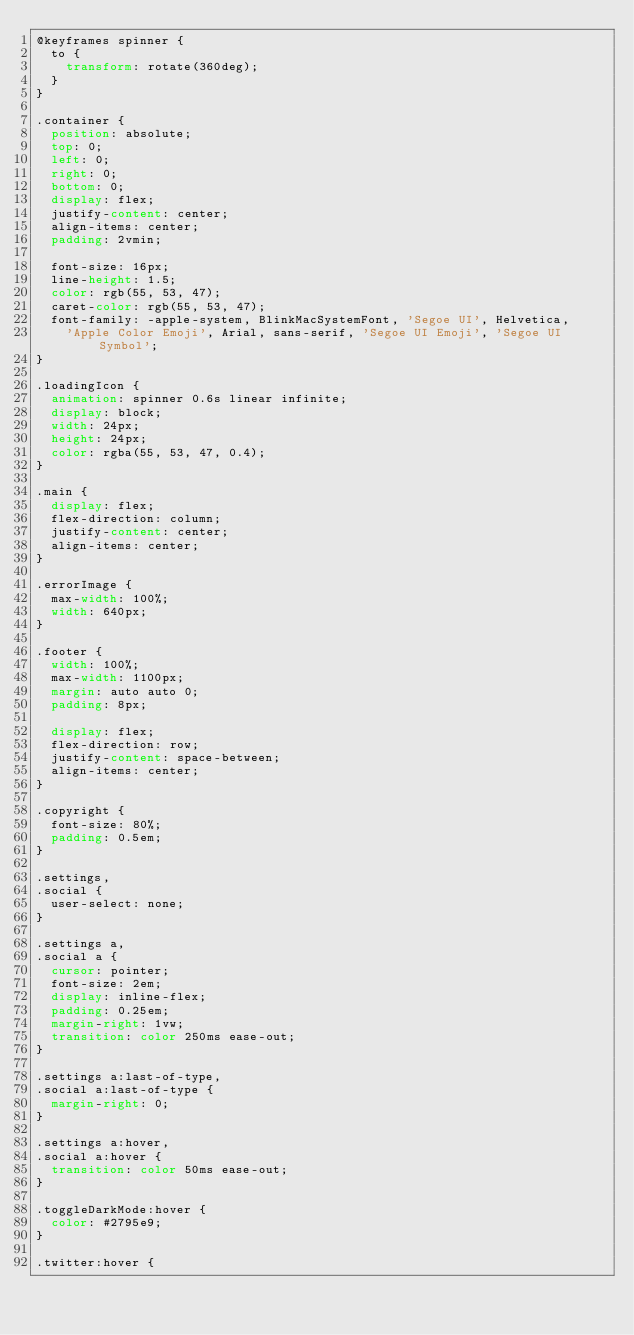Convert code to text. <code><loc_0><loc_0><loc_500><loc_500><_CSS_>@keyframes spinner {
  to {
    transform: rotate(360deg);
  }
}

.container {
  position: absolute;
  top: 0;
  left: 0;
  right: 0;
  bottom: 0;
  display: flex;
  justify-content: center;
  align-items: center;
  padding: 2vmin;

  font-size: 16px;
  line-height: 1.5;
  color: rgb(55, 53, 47);
  caret-color: rgb(55, 53, 47);
  font-family: -apple-system, BlinkMacSystemFont, 'Segoe UI', Helvetica,
    'Apple Color Emoji', Arial, sans-serif, 'Segoe UI Emoji', 'Segoe UI Symbol';
}

.loadingIcon {
  animation: spinner 0.6s linear infinite;
  display: block;
  width: 24px;
  height: 24px;
  color: rgba(55, 53, 47, 0.4);
}

.main {
  display: flex;
  flex-direction: column;
  justify-content: center;
  align-items: center;
}

.errorImage {
  max-width: 100%;
  width: 640px;
}

.footer {
  width: 100%;
  max-width: 1100px;
  margin: auto auto 0;
  padding: 8px;

  display: flex;
  flex-direction: row;
  justify-content: space-between;
  align-items: center;
}

.copyright {
  font-size: 80%;
  padding: 0.5em;
}

.settings,
.social {
  user-select: none;
}

.settings a,
.social a {
  cursor: pointer;
  font-size: 2em;
  display: inline-flex;
  padding: 0.25em;
  margin-right: 1vw;
  transition: color 250ms ease-out;
}

.settings a:last-of-type,
.social a:last-of-type {
  margin-right: 0;
}

.settings a:hover,
.social a:hover {
  transition: color 50ms ease-out;
}

.toggleDarkMode:hover {
  color: #2795e9;
}

.twitter:hover {</code> 